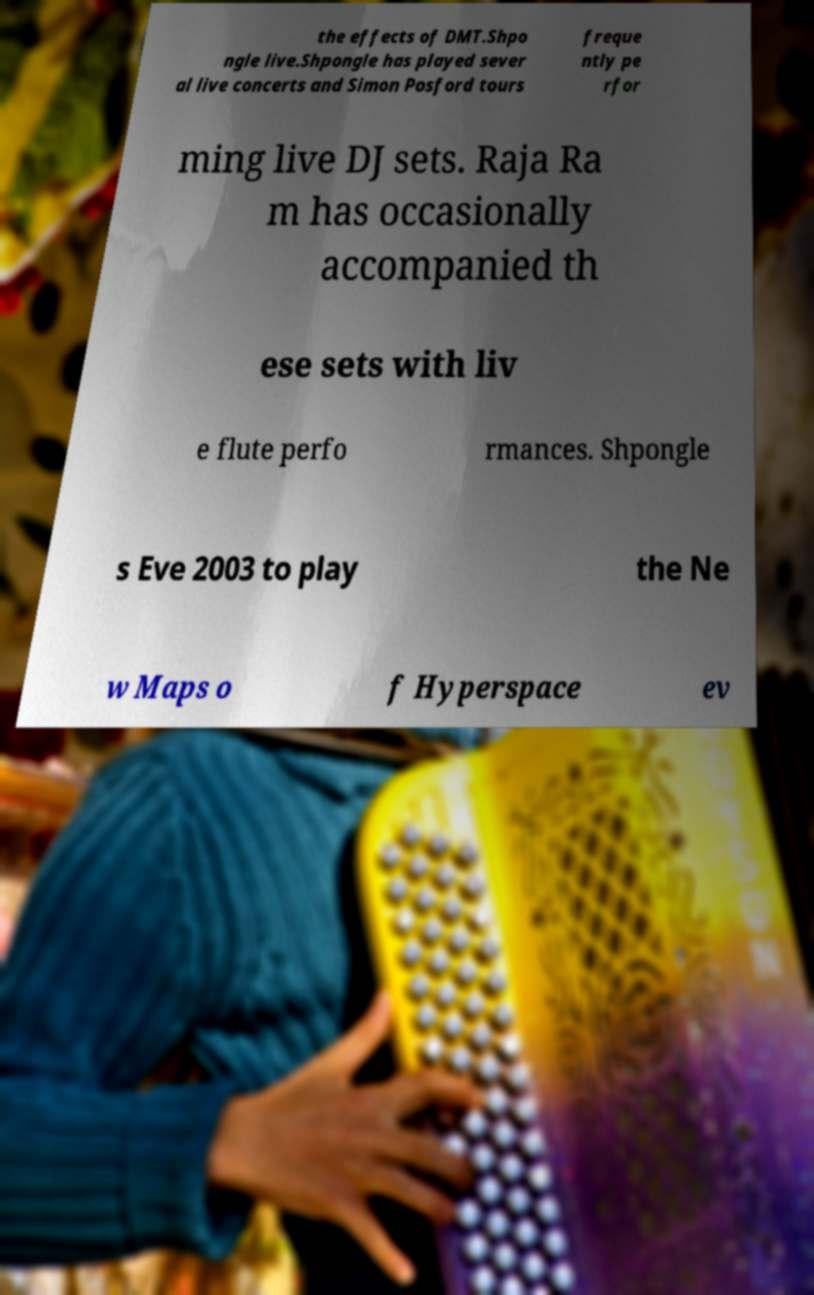Can you read and provide the text displayed in the image?This photo seems to have some interesting text. Can you extract and type it out for me? the effects of DMT.Shpo ngle live.Shpongle has played sever al live concerts and Simon Posford tours freque ntly pe rfor ming live DJ sets. Raja Ra m has occasionally accompanied th ese sets with liv e flute perfo rmances. Shpongle s Eve 2003 to play the Ne w Maps o f Hyperspace ev 